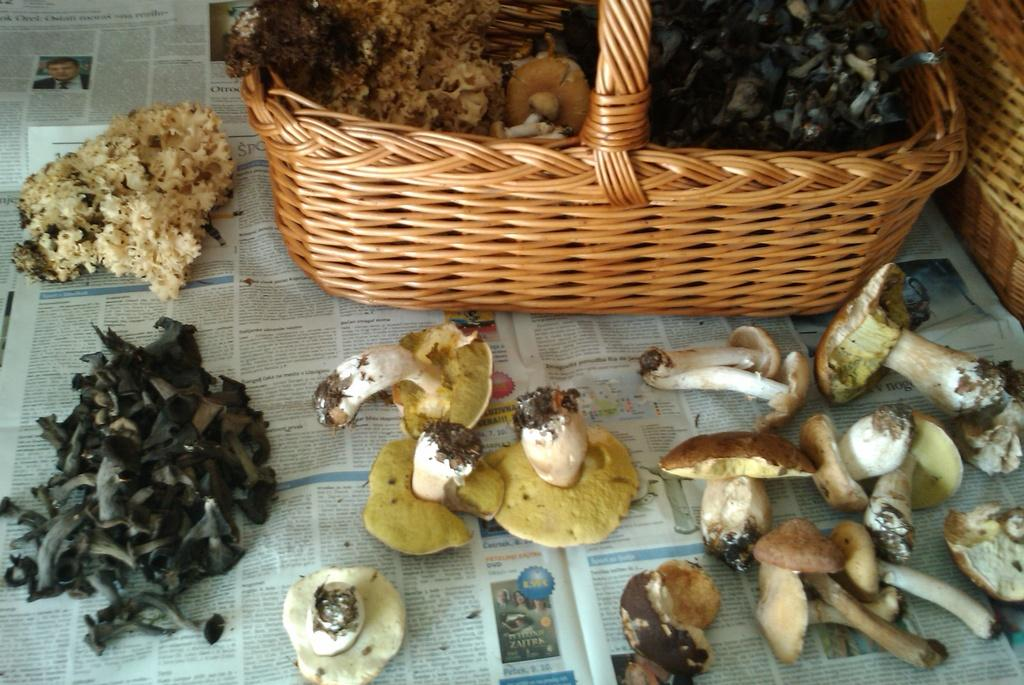What type of fungi can be seen in the image? There are mushrooms in the image. What are the baskets used for in the image? The baskets are likely used for carrying or storing the food items in the image. What type of food items are present in the image? There are food items in the image, but the specific types are not mentioned in the facts. What is the paper used for in the image? The purpose of the paper in the image is not mentioned in the facts. Can you describe any other objects in the image? There are other objects in the image, but their specific nature is not mentioned in the facts. What type of map can be seen in the image? There is no map present in the image. How low are the mushrooms in the image? The height of the mushrooms in the image is not mentioned in the facts. 